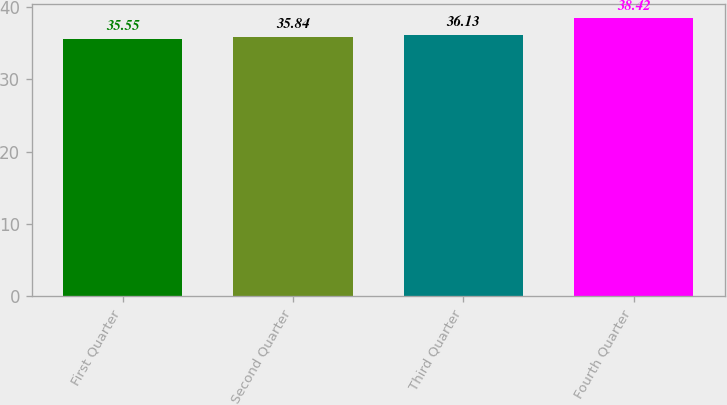<chart> <loc_0><loc_0><loc_500><loc_500><bar_chart><fcel>First Quarter<fcel>Second Quarter<fcel>Third Quarter<fcel>Fourth Quarter<nl><fcel>35.55<fcel>35.84<fcel>36.13<fcel>38.42<nl></chart> 